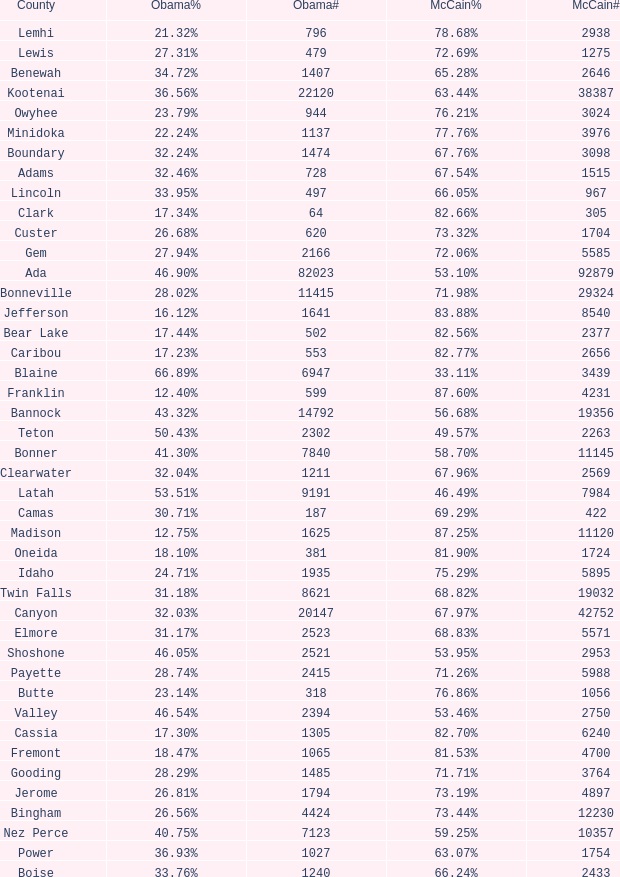For Gem County, what was the Obama vote percentage? 27.94%. I'm looking to parse the entire table for insights. Could you assist me with that? {'header': ['County', 'Obama%', 'Obama#', 'McCain%', 'McCain#'], 'rows': [['Lemhi', '21.32%', '796', '78.68%', '2938'], ['Lewis', '27.31%', '479', '72.69%', '1275'], ['Benewah', '34.72%', '1407', '65.28%', '2646'], ['Kootenai', '36.56%', '22120', '63.44%', '38387'], ['Owyhee', '23.79%', '944', '76.21%', '3024'], ['Minidoka', '22.24%', '1137', '77.76%', '3976'], ['Boundary', '32.24%', '1474', '67.76%', '3098'], ['Adams', '32.46%', '728', '67.54%', '1515'], ['Lincoln', '33.95%', '497', '66.05%', '967'], ['Clark', '17.34%', '64', '82.66%', '305'], ['Custer', '26.68%', '620', '73.32%', '1704'], ['Gem', '27.94%', '2166', '72.06%', '5585'], ['Ada', '46.90%', '82023', '53.10%', '92879'], ['Bonneville', '28.02%', '11415', '71.98%', '29324'], ['Jefferson', '16.12%', '1641', '83.88%', '8540'], ['Bear Lake', '17.44%', '502', '82.56%', '2377'], ['Caribou', '17.23%', '553', '82.77%', '2656'], ['Blaine', '66.89%', '6947', '33.11%', '3439'], ['Franklin', '12.40%', '599', '87.60%', '4231'], ['Bannock', '43.32%', '14792', '56.68%', '19356'], ['Teton', '50.43%', '2302', '49.57%', '2263'], ['Bonner', '41.30%', '7840', '58.70%', '11145'], ['Clearwater', '32.04%', '1211', '67.96%', '2569'], ['Latah', '53.51%', '9191', '46.49%', '7984'], ['Camas', '30.71%', '187', '69.29%', '422'], ['Madison', '12.75%', '1625', '87.25%', '11120'], ['Oneida', '18.10%', '381', '81.90%', '1724'], ['Idaho', '24.71%', '1935', '75.29%', '5895'], ['Twin Falls', '31.18%', '8621', '68.82%', '19032'], ['Canyon', '32.03%', '20147', '67.97%', '42752'], ['Elmore', '31.17%', '2523', '68.83%', '5571'], ['Shoshone', '46.05%', '2521', '53.95%', '2953'], ['Payette', '28.74%', '2415', '71.26%', '5988'], ['Butte', '23.14%', '318', '76.86%', '1056'], ['Valley', '46.54%', '2394', '53.46%', '2750'], ['Cassia', '17.30%', '1305', '82.70%', '6240'], ['Fremont', '18.47%', '1065', '81.53%', '4700'], ['Gooding', '28.29%', '1485', '71.71%', '3764'], ['Jerome', '26.81%', '1794', '73.19%', '4897'], ['Bingham', '26.56%', '4424', '73.44%', '12230'], ['Nez Perce', '40.75%', '7123', '59.25%', '10357'], ['Power', '36.93%', '1027', '63.07%', '1754'], ['Boise', '33.76%', '1240', '66.24%', '2433']]} 